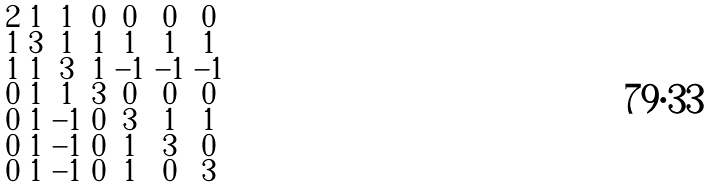<formula> <loc_0><loc_0><loc_500><loc_500>\begin{smallmatrix} 2 & 1 & 1 & 0 & 0 & 0 & 0 \\ 1 & 3 & 1 & 1 & 1 & 1 & 1 \\ 1 & 1 & 3 & 1 & - 1 & - 1 & - 1 \\ 0 & 1 & 1 & 3 & 0 & 0 & 0 \\ 0 & 1 & - 1 & 0 & 3 & 1 & 1 \\ 0 & 1 & - 1 & 0 & 1 & 3 & 0 \\ 0 & 1 & - 1 & 0 & 1 & 0 & 3 \end{smallmatrix}</formula> 